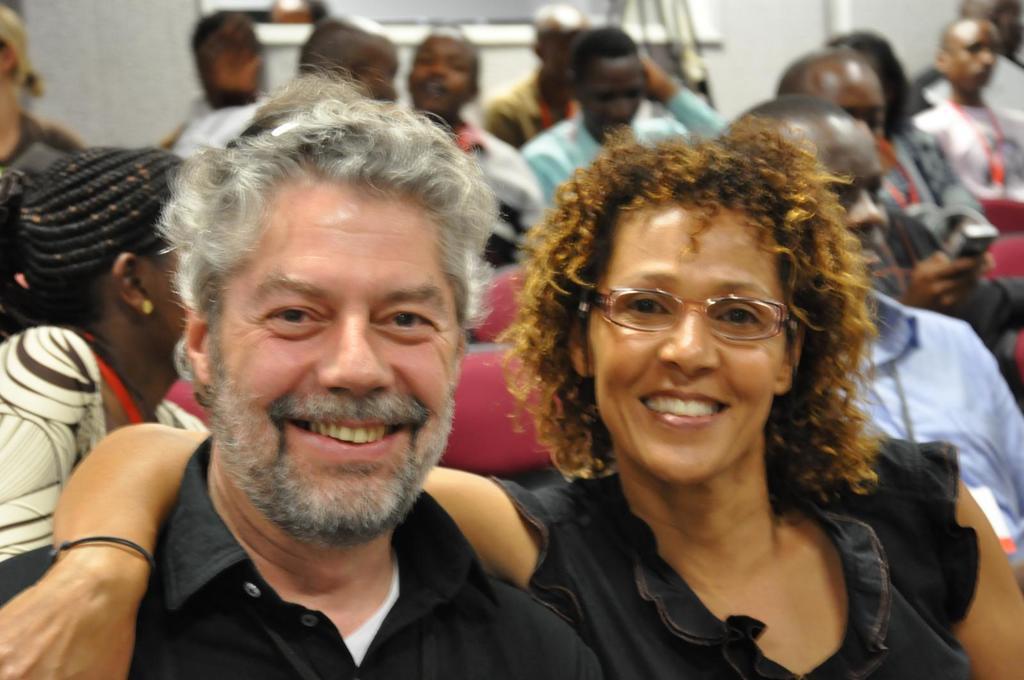Can you describe this image briefly? In this picture there is a woman placed his hand on a person beside her and there are few other persons sitting behind them. 